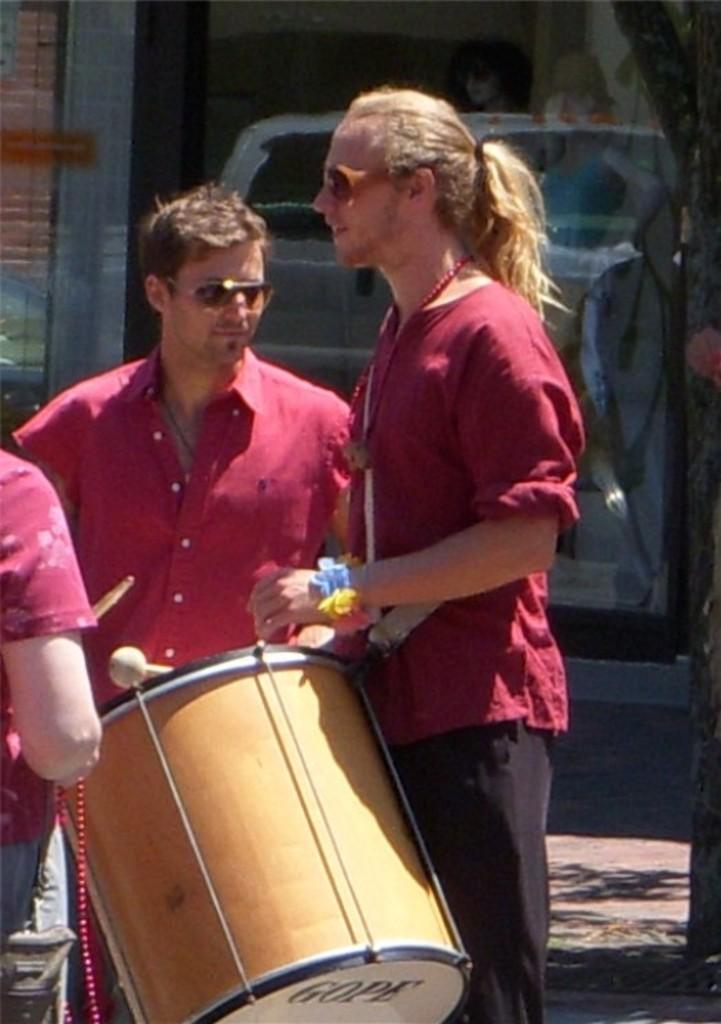How many people are in the image? There are three people in the image. What are two of the people holding? Two of the people are holding drums. What are the two people holding drums doing? The two people holding drums are playing them. What type of wire is being used to smash the drums in the image? There is no wire or smashing of drums present in the image. 